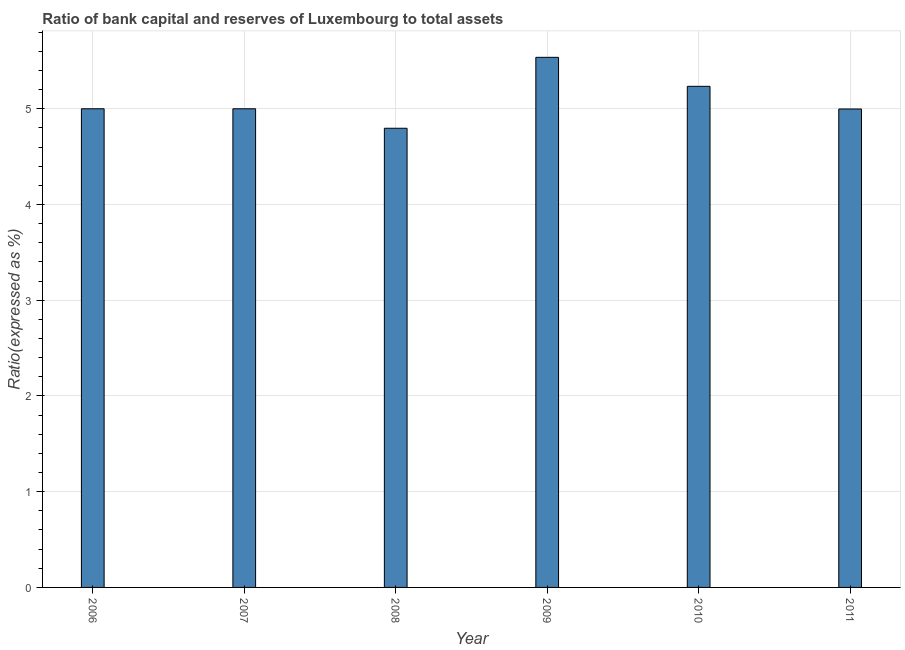Does the graph contain any zero values?
Offer a terse response. No. What is the title of the graph?
Provide a succinct answer. Ratio of bank capital and reserves of Luxembourg to total assets. What is the label or title of the Y-axis?
Provide a succinct answer. Ratio(expressed as %). What is the bank capital to assets ratio in 2011?
Your answer should be compact. 5. Across all years, what is the maximum bank capital to assets ratio?
Ensure brevity in your answer.  5.54. Across all years, what is the minimum bank capital to assets ratio?
Provide a succinct answer. 4.8. In which year was the bank capital to assets ratio minimum?
Your response must be concise. 2008. What is the sum of the bank capital to assets ratio?
Make the answer very short. 30.57. What is the difference between the bank capital to assets ratio in 2009 and 2010?
Offer a terse response. 0.3. What is the average bank capital to assets ratio per year?
Give a very brief answer. 5.09. What is the median bank capital to assets ratio?
Give a very brief answer. 5. In how many years, is the bank capital to assets ratio greater than 4.8 %?
Offer a terse response. 5. What is the ratio of the bank capital to assets ratio in 2010 to that in 2011?
Keep it short and to the point. 1.05. Is the bank capital to assets ratio in 2006 less than that in 2008?
Offer a terse response. No. Is the difference between the bank capital to assets ratio in 2007 and 2009 greater than the difference between any two years?
Your answer should be very brief. No. What is the difference between the highest and the second highest bank capital to assets ratio?
Offer a terse response. 0.3. What is the difference between the highest and the lowest bank capital to assets ratio?
Your answer should be compact. 0.74. Are all the bars in the graph horizontal?
Keep it short and to the point. No. How many years are there in the graph?
Your answer should be compact. 6. What is the Ratio(expressed as %) of 2007?
Your answer should be very brief. 5. What is the Ratio(expressed as %) in 2008?
Keep it short and to the point. 4.8. What is the Ratio(expressed as %) in 2009?
Provide a short and direct response. 5.54. What is the Ratio(expressed as %) of 2010?
Your answer should be very brief. 5.23. What is the Ratio(expressed as %) of 2011?
Provide a succinct answer. 5. What is the difference between the Ratio(expressed as %) in 2006 and 2007?
Keep it short and to the point. 0. What is the difference between the Ratio(expressed as %) in 2006 and 2008?
Provide a short and direct response. 0.2. What is the difference between the Ratio(expressed as %) in 2006 and 2009?
Ensure brevity in your answer.  -0.54. What is the difference between the Ratio(expressed as %) in 2006 and 2010?
Your answer should be compact. -0.23. What is the difference between the Ratio(expressed as %) in 2006 and 2011?
Ensure brevity in your answer.  0. What is the difference between the Ratio(expressed as %) in 2007 and 2008?
Ensure brevity in your answer.  0.2. What is the difference between the Ratio(expressed as %) in 2007 and 2009?
Provide a short and direct response. -0.54. What is the difference between the Ratio(expressed as %) in 2007 and 2010?
Provide a succinct answer. -0.23. What is the difference between the Ratio(expressed as %) in 2007 and 2011?
Offer a terse response. 0. What is the difference between the Ratio(expressed as %) in 2008 and 2009?
Ensure brevity in your answer.  -0.74. What is the difference between the Ratio(expressed as %) in 2008 and 2010?
Provide a succinct answer. -0.44. What is the difference between the Ratio(expressed as %) in 2008 and 2011?
Your response must be concise. -0.2. What is the difference between the Ratio(expressed as %) in 2009 and 2010?
Ensure brevity in your answer.  0.3. What is the difference between the Ratio(expressed as %) in 2009 and 2011?
Offer a terse response. 0.54. What is the difference between the Ratio(expressed as %) in 2010 and 2011?
Keep it short and to the point. 0.24. What is the ratio of the Ratio(expressed as %) in 2006 to that in 2007?
Your response must be concise. 1. What is the ratio of the Ratio(expressed as %) in 2006 to that in 2008?
Provide a succinct answer. 1.04. What is the ratio of the Ratio(expressed as %) in 2006 to that in 2009?
Your answer should be compact. 0.9. What is the ratio of the Ratio(expressed as %) in 2006 to that in 2010?
Offer a terse response. 0.95. What is the ratio of the Ratio(expressed as %) in 2006 to that in 2011?
Provide a succinct answer. 1. What is the ratio of the Ratio(expressed as %) in 2007 to that in 2008?
Your answer should be compact. 1.04. What is the ratio of the Ratio(expressed as %) in 2007 to that in 2009?
Ensure brevity in your answer.  0.9. What is the ratio of the Ratio(expressed as %) in 2007 to that in 2010?
Your answer should be very brief. 0.95. What is the ratio of the Ratio(expressed as %) in 2007 to that in 2011?
Keep it short and to the point. 1. What is the ratio of the Ratio(expressed as %) in 2008 to that in 2009?
Keep it short and to the point. 0.87. What is the ratio of the Ratio(expressed as %) in 2008 to that in 2010?
Offer a terse response. 0.92. What is the ratio of the Ratio(expressed as %) in 2008 to that in 2011?
Keep it short and to the point. 0.96. What is the ratio of the Ratio(expressed as %) in 2009 to that in 2010?
Your response must be concise. 1.06. What is the ratio of the Ratio(expressed as %) in 2009 to that in 2011?
Provide a short and direct response. 1.11. What is the ratio of the Ratio(expressed as %) in 2010 to that in 2011?
Keep it short and to the point. 1.05. 